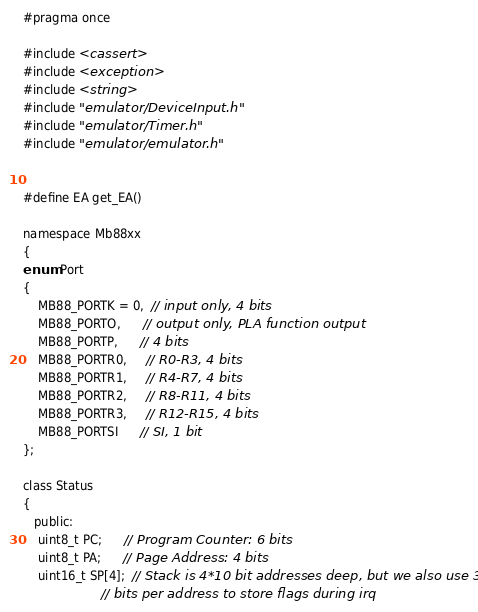Convert code to text. <code><loc_0><loc_0><loc_500><loc_500><_C_>#pragma once

#include <cassert>
#include <exception>
#include <string>
#include "emulator/DeviceInput.h"
#include "emulator/Timer.h"
#include "emulator/emulator.h"


#define EA get_EA()

namespace Mb88xx
{
enum Port
{
    MB88_PORTK = 0,  // input only, 4 bits
    MB88_PORTO,      // output only, PLA function output
    MB88_PORTP,      // 4 bits
    MB88_PORTR0,     // R0-R3, 4 bits
    MB88_PORTR1,     // R4-R7, 4 bits
    MB88_PORTR2,     // R8-R11, 4 bits
    MB88_PORTR3,     // R12-R15, 4 bits
    MB88_PORTSI      // SI, 1 bit
};

class Status
{
   public:
    uint8_t PC;      // Program Counter: 6 bits
    uint8_t PA;      // Page Address: 4 bits
    uint16_t SP[4];  // Stack is 4*10 bit addresses deep, but we also use 3 top
                     // bits per address to store flags during irq</code> 